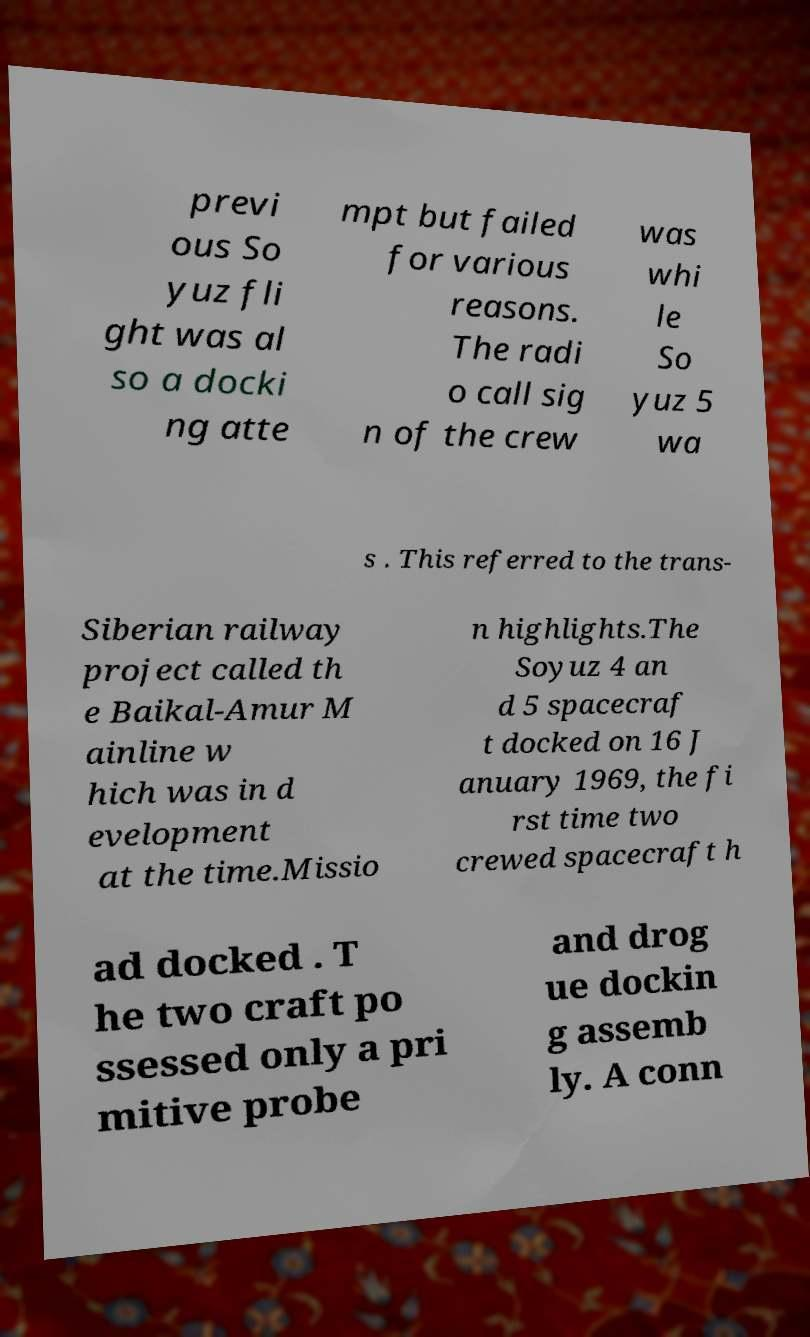Could you assist in decoding the text presented in this image and type it out clearly? previ ous So yuz fli ght was al so a docki ng atte mpt but failed for various reasons. The radi o call sig n of the crew was whi le So yuz 5 wa s . This referred to the trans- Siberian railway project called th e Baikal-Amur M ainline w hich was in d evelopment at the time.Missio n highlights.The Soyuz 4 an d 5 spacecraf t docked on 16 J anuary 1969, the fi rst time two crewed spacecraft h ad docked . T he two craft po ssessed only a pri mitive probe and drog ue dockin g assemb ly. A conn 